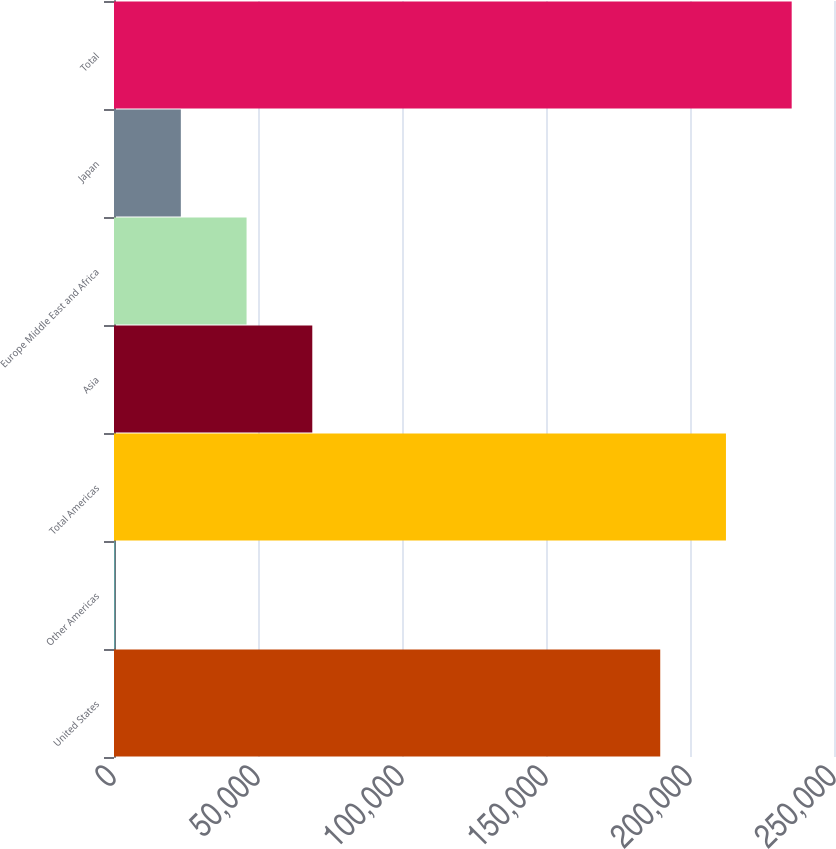Convert chart to OTSL. <chart><loc_0><loc_0><loc_500><loc_500><bar_chart><fcel>United States<fcel>Other Americas<fcel>Total Americas<fcel>Asia<fcel>Europe Middle East and Africa<fcel>Japan<fcel>Total<nl><fcel>189665<fcel>387<fcel>212486<fcel>68850.6<fcel>46029.4<fcel>23208.2<fcel>235307<nl></chart> 